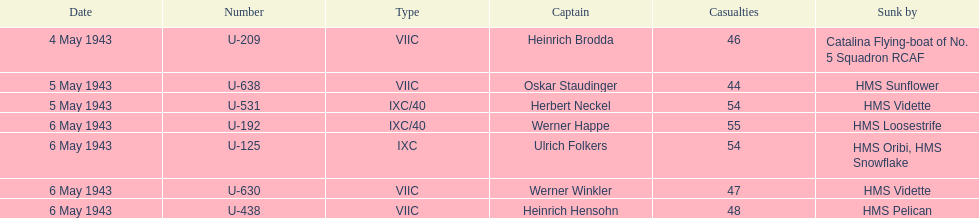What is the difference in the number of casualties on may 6 compared to may 4? 158. Parse the full table. {'header': ['Date', 'Number', 'Type', 'Captain', 'Casualties', 'Sunk by'], 'rows': [['4 May 1943', 'U-209', 'VIIC', 'Heinrich Brodda', '46', 'Catalina Flying-boat of No. 5 Squadron RCAF'], ['5 May 1943', 'U-638', 'VIIC', 'Oskar Staudinger', '44', 'HMS Sunflower'], ['5 May 1943', 'U-531', 'IXC/40', 'Herbert Neckel', '54', 'HMS Vidette'], ['6 May 1943', 'U-192', 'IXC/40', 'Werner Happe', '55', 'HMS Loosestrife'], ['6 May 1943', 'U-125', 'IXC', 'Ulrich Folkers', '54', 'HMS Oribi, HMS Snowflake'], ['6 May 1943', 'U-630', 'VIIC', 'Werner Winkler', '47', 'HMS Vidette'], ['6 May 1943', 'U-438', 'VIIC', 'Heinrich Hensohn', '48', 'HMS Pelican']]} 